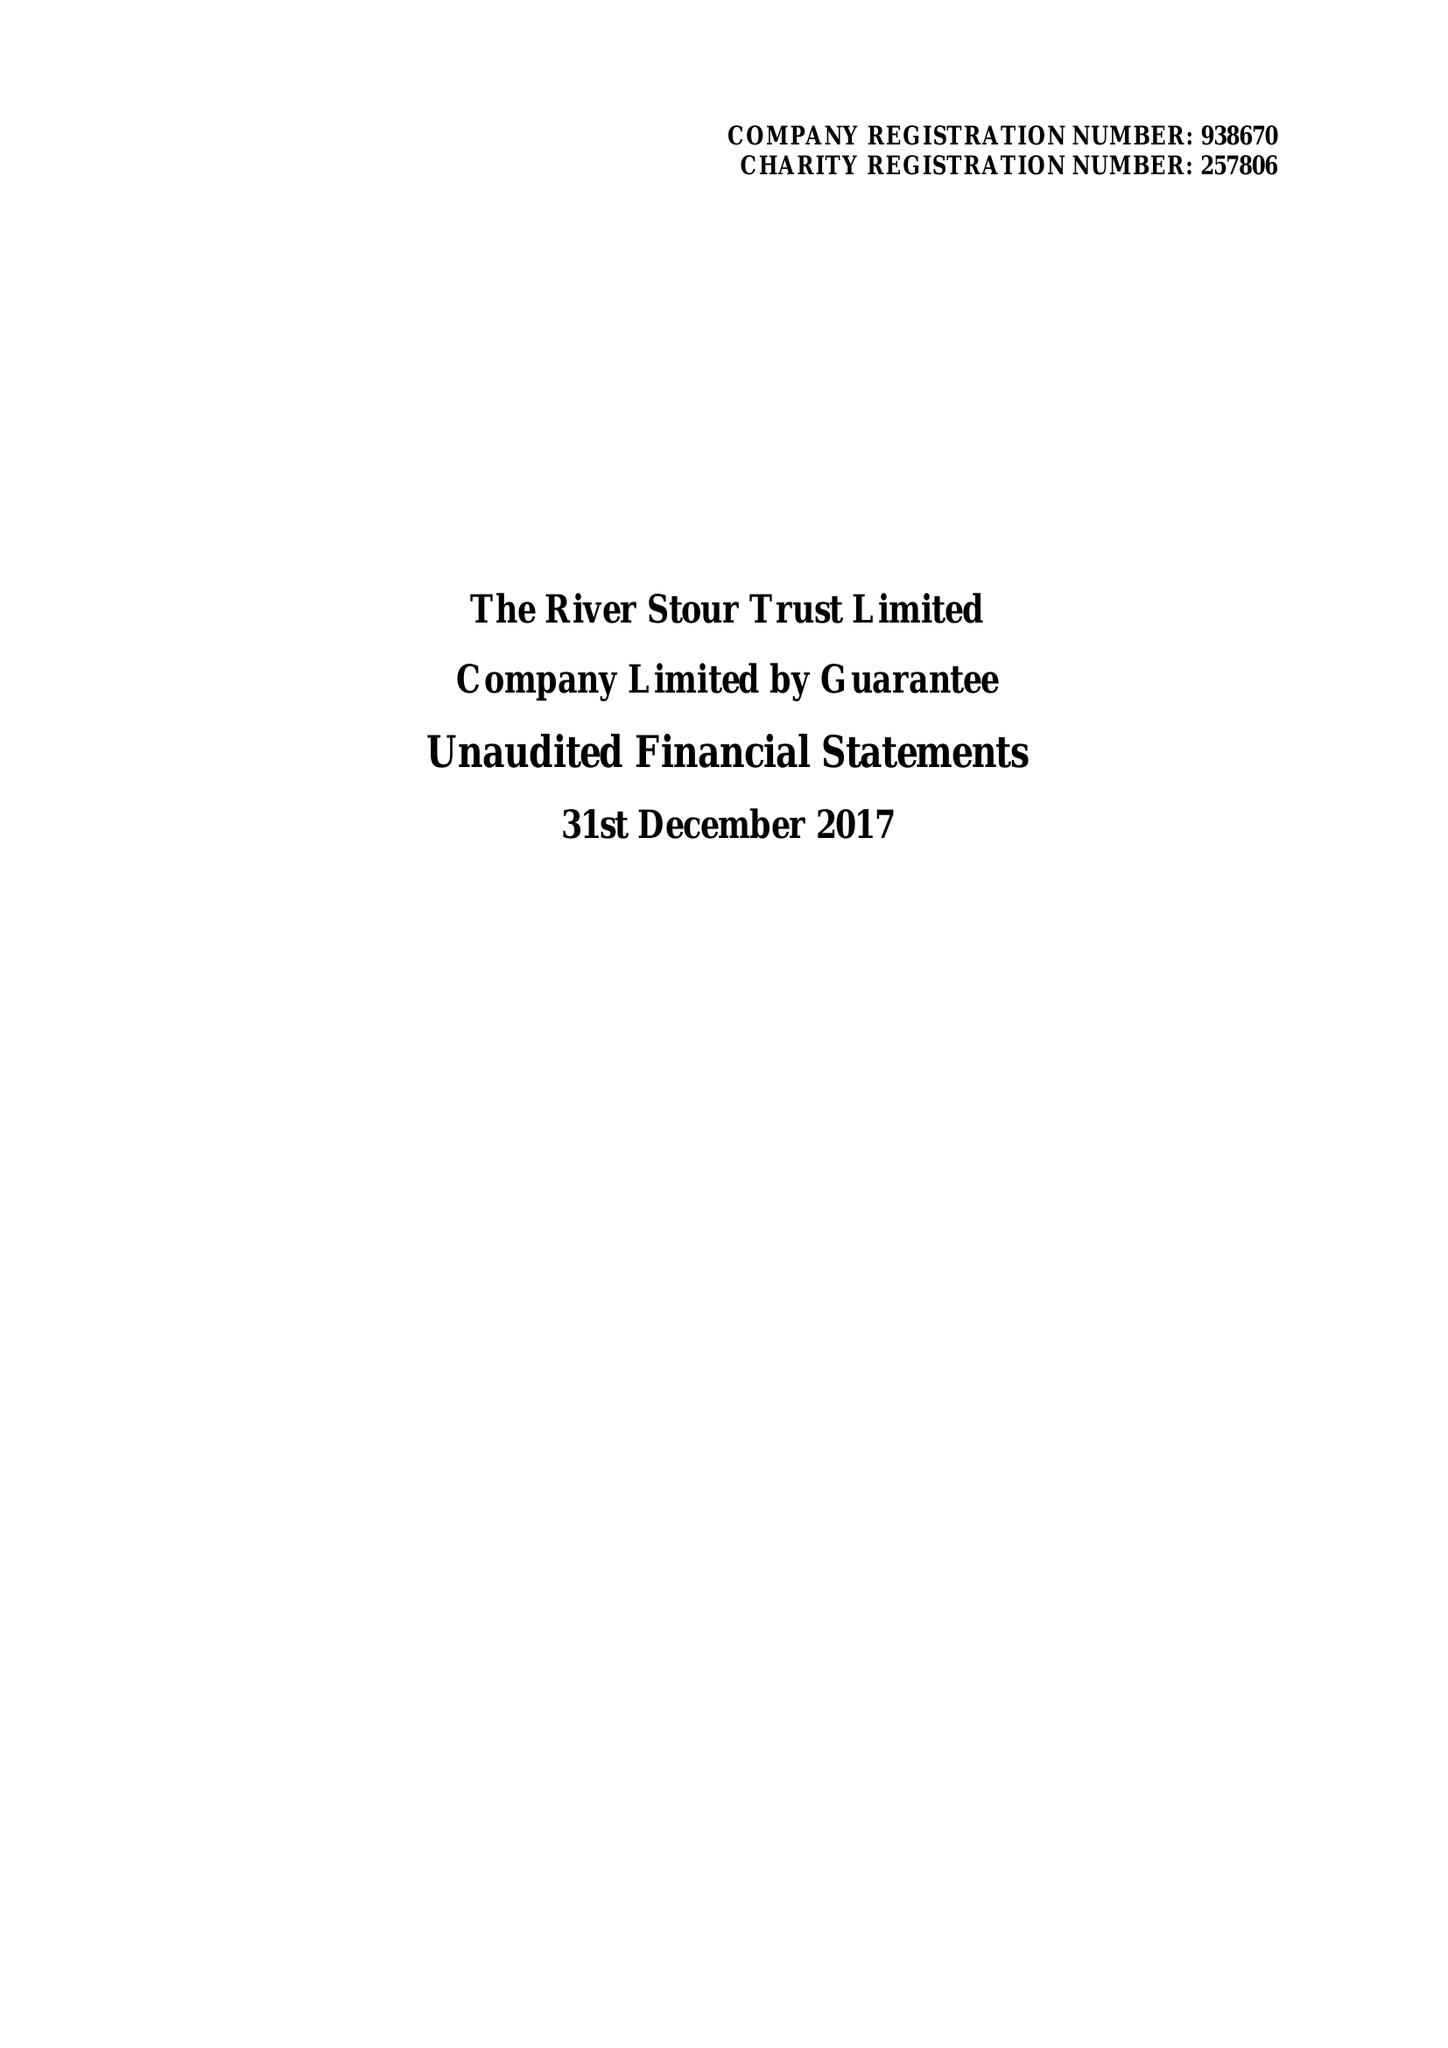What is the value for the address__street_line?
Answer the question using a single word or phrase. None 